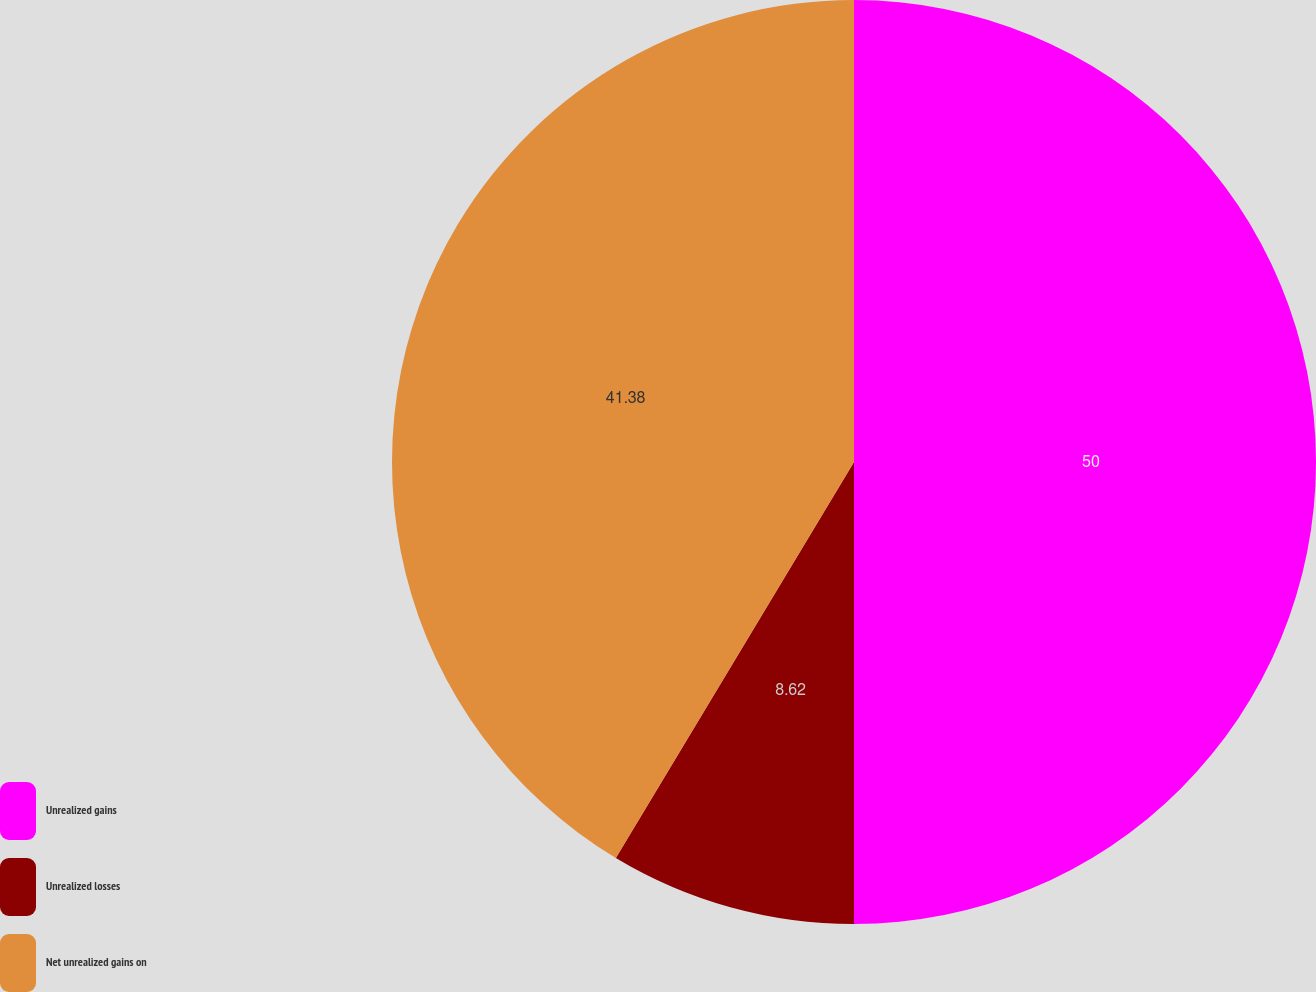Convert chart to OTSL. <chart><loc_0><loc_0><loc_500><loc_500><pie_chart><fcel>Unrealized gains<fcel>Unrealized losses<fcel>Net unrealized gains on<nl><fcel>50.0%<fcel>8.62%<fcel>41.38%<nl></chart> 